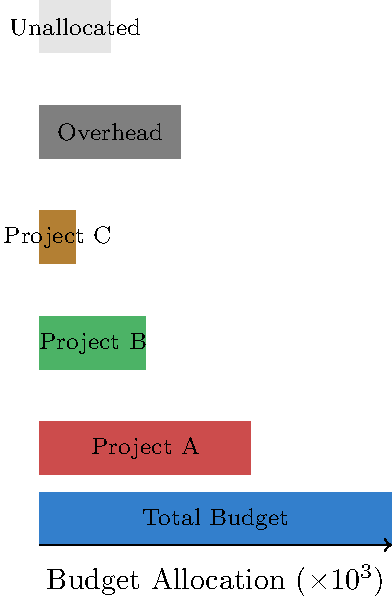Based on the Sankey diagram showing budget allocation for a client project, what percentage of the total budget should be reallocated from overhead and unallocated funds to maximize the resources available for client projects (A, B, and C) while maintaining a 10% contingency? To solve this problem, let's follow these steps:

1. Identify the total budget: $100,000 (100 units in the diagram)

2. Calculate the current allocation:
   - Project A: $60,000 (60%)
   - Project B: $30,000 (30%)
   - Project C: $10,000 (10%)
   - Overhead: $40,000 (40%)
   - Unallocated: $20,000 (20%)

3. Calculate the current allocation for client projects:
   $60,000 + $30,000 + $10,000 = $100,000 (60%)

4. Determine the target allocation:
   - Maintain 10% contingency: $10,000 (10 units)
   - Maximize resources for client projects: 90% of total budget

5. Calculate the amount to be reallocated:
   Target allocation for projects: 90% of $100,000 = $90,000
   Current allocation for projects: $60,000
   Amount to be reallocated: $90,000 - $60,000 = $30,000

6. Calculate the percentage to be reallocated:
   Percentage = (Amount to be reallocated / Total budget) × 100
   = ($30,000 / $100,000) × 100 = 30%

Therefore, 30% of the total budget should be reallocated from overhead and unallocated funds to maximize resources for client projects while maintaining a 10% contingency.
Answer: 30% 